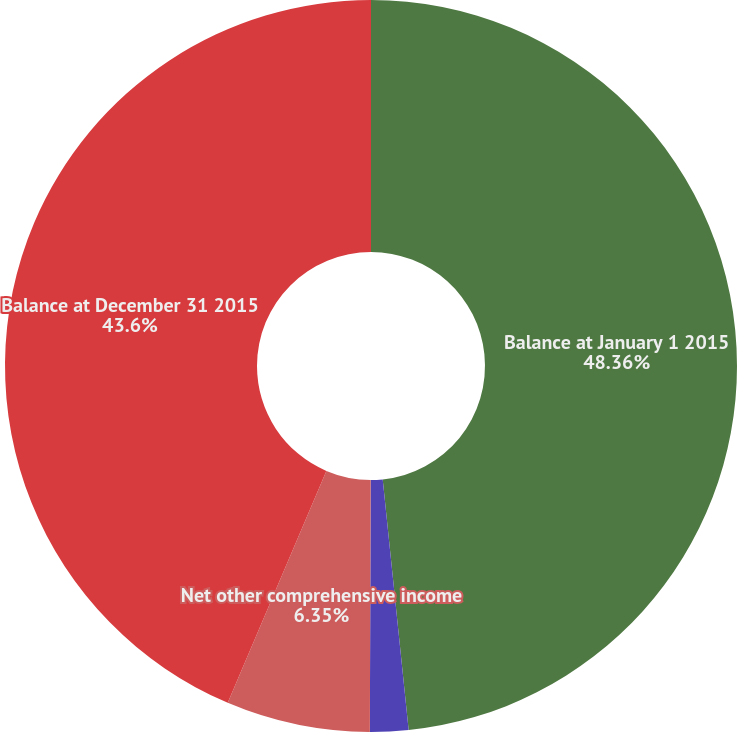Convert chart to OTSL. <chart><loc_0><loc_0><loc_500><loc_500><pie_chart><fcel>Balance at January 1 2015<fcel>Recorded into AOCI<fcel>Net other comprehensive income<fcel>Balance at December 31 2015<nl><fcel>48.36%<fcel>1.69%<fcel>6.35%<fcel>43.6%<nl></chart> 